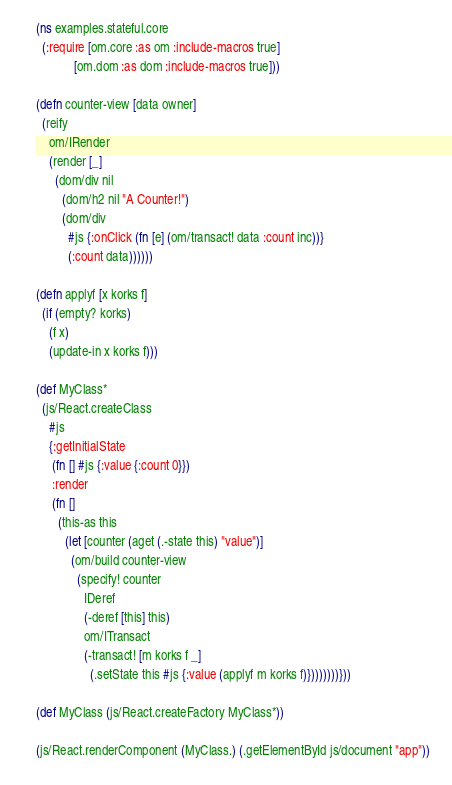<code> <loc_0><loc_0><loc_500><loc_500><_Clojure_>(ns examples.stateful.core
  (:require [om.core :as om :include-macros true]
            [om.dom :as dom :include-macros true]))

(defn counter-view [data owner]
  (reify
    om/IRender 
    (render [_]
      (dom/div nil
        (dom/h2 nil "A Counter!")
        (dom/div
          #js {:onClick (fn [e] (om/transact! data :count inc))}
          (:count data))))))

(defn applyf [x korks f]
  (if (empty? korks)
    (f x)
    (update-in x korks f)))

(def MyClass*
  (js/React.createClass
    #js
    {:getInitialState
     (fn [] #js {:value {:count 0}})
     :render
     (fn []
       (this-as this
         (let [counter (aget (.-state this) "value")]
           (om/build counter-view 
             (specify! counter
               IDeref
               (-deref [this] this)
               om/ITransact
               (-transact! [m korks f _]
                 (.setState this #js {:value (applyf m korks f)})))))))}))

(def MyClass (js/React.createFactory MyClass*))

(js/React.renderComponent (MyClass.) (.getElementById js/document "app"))
</code> 